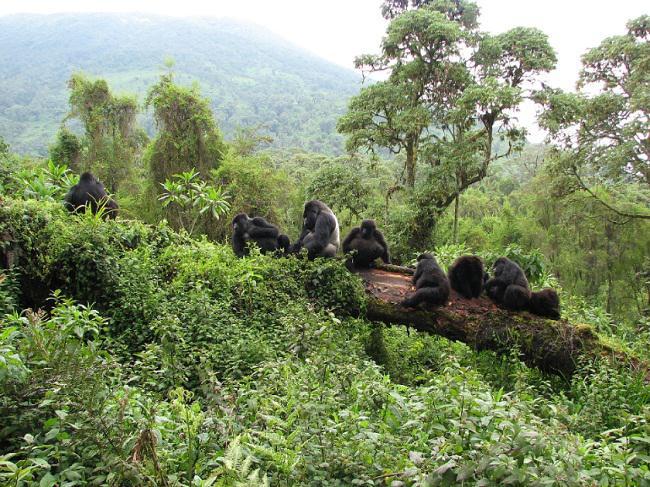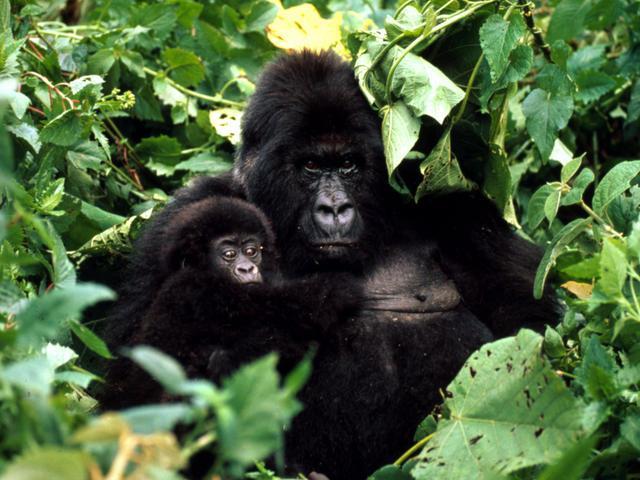The first image is the image on the left, the second image is the image on the right. For the images shown, is this caption "A single adult gorilla is holding a baby." true? Answer yes or no. Yes. The first image is the image on the left, the second image is the image on the right. For the images shown, is this caption "An image shows exactly one adult gorilla in close contact with a baby gorilla." true? Answer yes or no. Yes. 